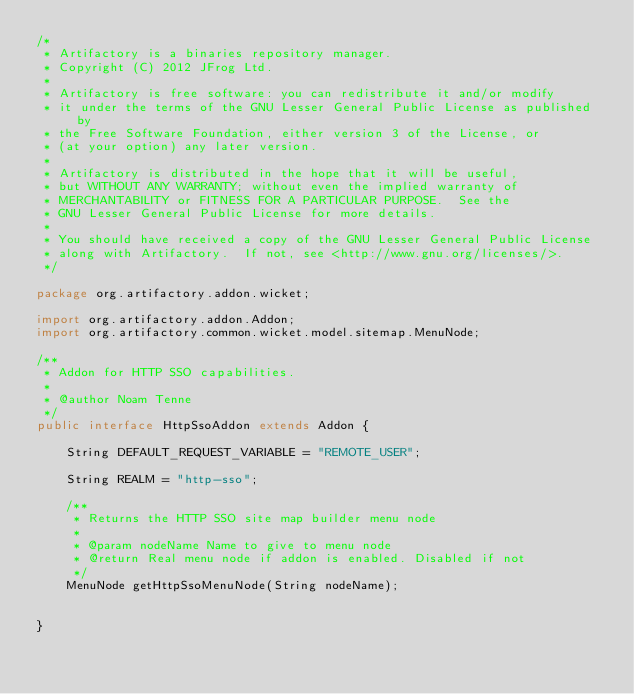Convert code to text. <code><loc_0><loc_0><loc_500><loc_500><_Java_>/*
 * Artifactory is a binaries repository manager.
 * Copyright (C) 2012 JFrog Ltd.
 *
 * Artifactory is free software: you can redistribute it and/or modify
 * it under the terms of the GNU Lesser General Public License as published by
 * the Free Software Foundation, either version 3 of the License, or
 * (at your option) any later version.
 *
 * Artifactory is distributed in the hope that it will be useful,
 * but WITHOUT ANY WARRANTY; without even the implied warranty of
 * MERCHANTABILITY or FITNESS FOR A PARTICULAR PURPOSE.  See the
 * GNU Lesser General Public License for more details.
 *
 * You should have received a copy of the GNU Lesser General Public License
 * along with Artifactory.  If not, see <http://www.gnu.org/licenses/>.
 */

package org.artifactory.addon.wicket;

import org.artifactory.addon.Addon;
import org.artifactory.common.wicket.model.sitemap.MenuNode;

/**
 * Addon for HTTP SSO capabilities.
 *
 * @author Noam Tenne
 */
public interface HttpSsoAddon extends Addon {

    String DEFAULT_REQUEST_VARIABLE = "REMOTE_USER";

    String REALM = "http-sso";

    /**
     * Returns the HTTP SSO site map builder menu node
     *
     * @param nodeName Name to give to menu node
     * @return Real menu node if addon is enabled. Disabled if not
     */
    MenuNode getHttpSsoMenuNode(String nodeName);


}
</code> 